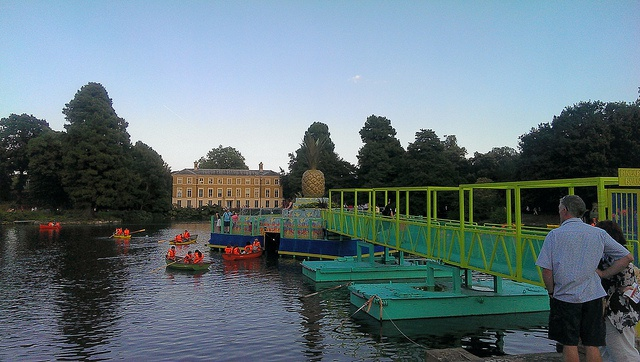Describe the objects in this image and their specific colors. I can see people in lightblue, black, gray, and maroon tones, people in lightblue, black, gray, and olive tones, boat in lightblue, black, darkgreen, and maroon tones, boat in lightblue, maroon, black, and brown tones, and people in lightblue, gray, black, teal, and darkgray tones in this image. 